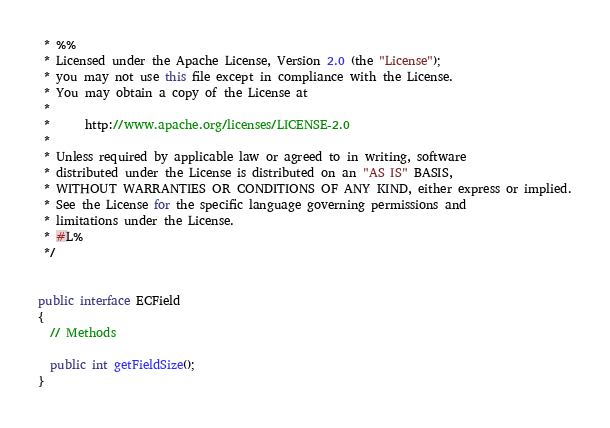Convert code to text. <code><loc_0><loc_0><loc_500><loc_500><_Java_> * %%
 * Licensed under the Apache License, Version 2.0 (the "License");
 * you may not use this file except in compliance with the License.
 * You may obtain a copy of the License at
 * 
 *      http://www.apache.org/licenses/LICENSE-2.0
 * 
 * Unless required by applicable law or agreed to in writing, software
 * distributed under the License is distributed on an "AS IS" BASIS,
 * WITHOUT WARRANTIES OR CONDITIONS OF ANY KIND, either express or implied.
 * See the License for the specific language governing permissions and
 * limitations under the License.
 * #L%
 */


public interface ECField
{
  // Methods

  public int getFieldSize();
}
</code> 